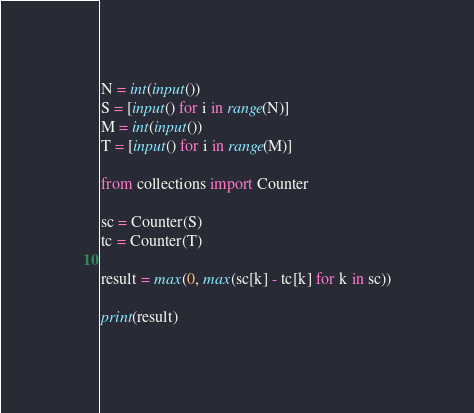Convert code to text. <code><loc_0><loc_0><loc_500><loc_500><_Python_>N = int(input())
S = [input() for i in range(N)]
M = int(input())
T = [input() for i in range(M)]

from collections import Counter

sc = Counter(S)
tc = Counter(T)

result = max(0, max(sc[k] - tc[k] for k in sc))

print(result)
</code> 